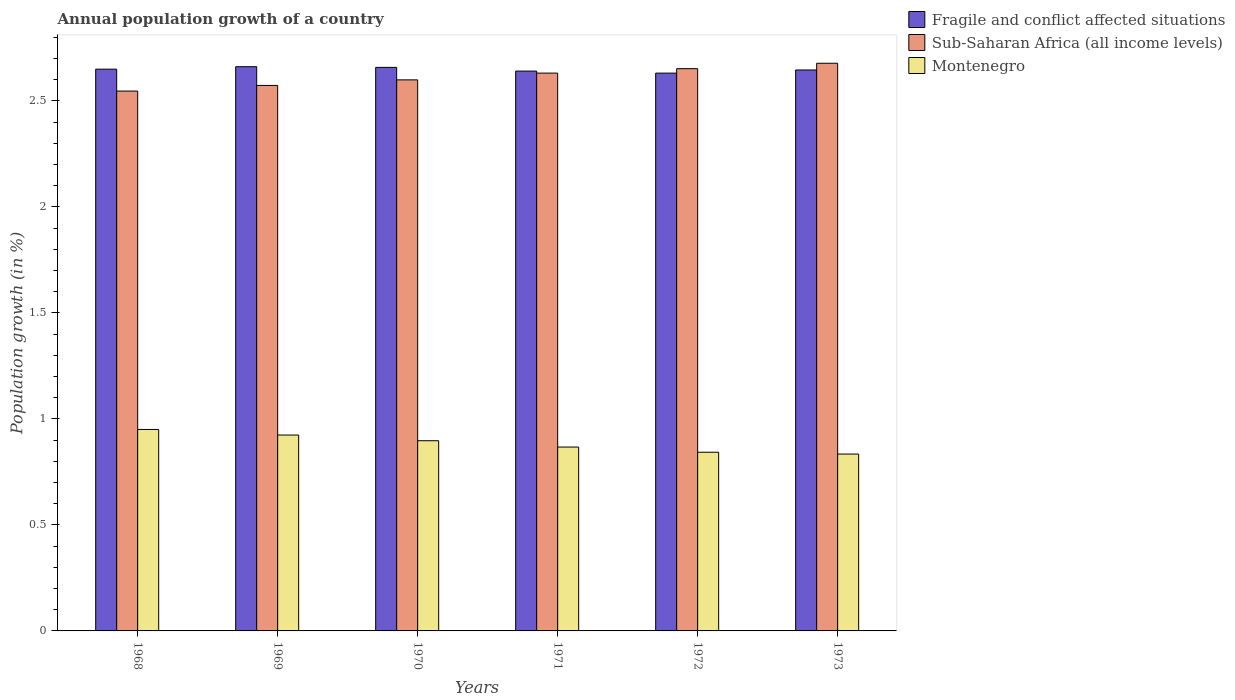How many different coloured bars are there?
Provide a succinct answer. 3. How many groups of bars are there?
Offer a very short reply. 6. Are the number of bars per tick equal to the number of legend labels?
Provide a short and direct response. Yes. How many bars are there on the 5th tick from the right?
Your response must be concise. 3. What is the annual population growth in Montenegro in 1968?
Make the answer very short. 0.95. Across all years, what is the maximum annual population growth in Sub-Saharan Africa (all income levels)?
Provide a succinct answer. 2.68. Across all years, what is the minimum annual population growth in Montenegro?
Give a very brief answer. 0.83. In which year was the annual population growth in Fragile and conflict affected situations maximum?
Offer a very short reply. 1969. In which year was the annual population growth in Sub-Saharan Africa (all income levels) minimum?
Provide a short and direct response. 1968. What is the total annual population growth in Fragile and conflict affected situations in the graph?
Offer a terse response. 15.89. What is the difference between the annual population growth in Fragile and conflict affected situations in 1970 and that in 1973?
Keep it short and to the point. 0.01. What is the difference between the annual population growth in Montenegro in 1969 and the annual population growth in Fragile and conflict affected situations in 1972?
Offer a very short reply. -1.71. What is the average annual population growth in Fragile and conflict affected situations per year?
Give a very brief answer. 2.65. In the year 1972, what is the difference between the annual population growth in Sub-Saharan Africa (all income levels) and annual population growth in Montenegro?
Offer a terse response. 1.81. What is the ratio of the annual population growth in Sub-Saharan Africa (all income levels) in 1970 to that in 1973?
Your answer should be very brief. 0.97. Is the difference between the annual population growth in Sub-Saharan Africa (all income levels) in 1971 and 1973 greater than the difference between the annual population growth in Montenegro in 1971 and 1973?
Provide a succinct answer. No. What is the difference between the highest and the second highest annual population growth in Montenegro?
Offer a very short reply. 0.03. What is the difference between the highest and the lowest annual population growth in Fragile and conflict affected situations?
Make the answer very short. 0.03. In how many years, is the annual population growth in Fragile and conflict affected situations greater than the average annual population growth in Fragile and conflict affected situations taken over all years?
Give a very brief answer. 3. What does the 3rd bar from the left in 1968 represents?
Provide a short and direct response. Montenegro. What does the 1st bar from the right in 1968 represents?
Offer a very short reply. Montenegro. Is it the case that in every year, the sum of the annual population growth in Montenegro and annual population growth in Sub-Saharan Africa (all income levels) is greater than the annual population growth in Fragile and conflict affected situations?
Provide a short and direct response. Yes. How many bars are there?
Provide a succinct answer. 18. What is the difference between two consecutive major ticks on the Y-axis?
Ensure brevity in your answer.  0.5. Are the values on the major ticks of Y-axis written in scientific E-notation?
Make the answer very short. No. Does the graph contain grids?
Make the answer very short. No. How are the legend labels stacked?
Keep it short and to the point. Vertical. What is the title of the graph?
Keep it short and to the point. Annual population growth of a country. What is the label or title of the X-axis?
Provide a succinct answer. Years. What is the label or title of the Y-axis?
Provide a succinct answer. Population growth (in %). What is the Population growth (in %) in Fragile and conflict affected situations in 1968?
Ensure brevity in your answer.  2.65. What is the Population growth (in %) of Sub-Saharan Africa (all income levels) in 1968?
Ensure brevity in your answer.  2.55. What is the Population growth (in %) in Montenegro in 1968?
Keep it short and to the point. 0.95. What is the Population growth (in %) in Fragile and conflict affected situations in 1969?
Your response must be concise. 2.66. What is the Population growth (in %) in Sub-Saharan Africa (all income levels) in 1969?
Keep it short and to the point. 2.57. What is the Population growth (in %) of Montenegro in 1969?
Provide a succinct answer. 0.92. What is the Population growth (in %) in Fragile and conflict affected situations in 1970?
Give a very brief answer. 2.66. What is the Population growth (in %) of Sub-Saharan Africa (all income levels) in 1970?
Provide a succinct answer. 2.6. What is the Population growth (in %) of Montenegro in 1970?
Provide a succinct answer. 0.9. What is the Population growth (in %) of Fragile and conflict affected situations in 1971?
Your answer should be compact. 2.64. What is the Population growth (in %) in Sub-Saharan Africa (all income levels) in 1971?
Ensure brevity in your answer.  2.63. What is the Population growth (in %) in Montenegro in 1971?
Ensure brevity in your answer.  0.87. What is the Population growth (in %) in Fragile and conflict affected situations in 1972?
Keep it short and to the point. 2.63. What is the Population growth (in %) in Sub-Saharan Africa (all income levels) in 1972?
Your answer should be very brief. 2.65. What is the Population growth (in %) of Montenegro in 1972?
Offer a very short reply. 0.84. What is the Population growth (in %) in Fragile and conflict affected situations in 1973?
Ensure brevity in your answer.  2.65. What is the Population growth (in %) of Sub-Saharan Africa (all income levels) in 1973?
Ensure brevity in your answer.  2.68. What is the Population growth (in %) in Montenegro in 1973?
Offer a terse response. 0.83. Across all years, what is the maximum Population growth (in %) of Fragile and conflict affected situations?
Your response must be concise. 2.66. Across all years, what is the maximum Population growth (in %) of Sub-Saharan Africa (all income levels)?
Offer a very short reply. 2.68. Across all years, what is the maximum Population growth (in %) in Montenegro?
Ensure brevity in your answer.  0.95. Across all years, what is the minimum Population growth (in %) in Fragile and conflict affected situations?
Ensure brevity in your answer.  2.63. Across all years, what is the minimum Population growth (in %) in Sub-Saharan Africa (all income levels)?
Give a very brief answer. 2.55. Across all years, what is the minimum Population growth (in %) of Montenegro?
Your response must be concise. 0.83. What is the total Population growth (in %) in Fragile and conflict affected situations in the graph?
Your response must be concise. 15.89. What is the total Population growth (in %) of Sub-Saharan Africa (all income levels) in the graph?
Offer a terse response. 15.68. What is the total Population growth (in %) in Montenegro in the graph?
Provide a short and direct response. 5.32. What is the difference between the Population growth (in %) of Fragile and conflict affected situations in 1968 and that in 1969?
Offer a terse response. -0.01. What is the difference between the Population growth (in %) of Sub-Saharan Africa (all income levels) in 1968 and that in 1969?
Your answer should be very brief. -0.03. What is the difference between the Population growth (in %) of Montenegro in 1968 and that in 1969?
Your answer should be very brief. 0.03. What is the difference between the Population growth (in %) in Fragile and conflict affected situations in 1968 and that in 1970?
Your answer should be very brief. -0.01. What is the difference between the Population growth (in %) in Sub-Saharan Africa (all income levels) in 1968 and that in 1970?
Provide a short and direct response. -0.05. What is the difference between the Population growth (in %) in Montenegro in 1968 and that in 1970?
Give a very brief answer. 0.05. What is the difference between the Population growth (in %) of Fragile and conflict affected situations in 1968 and that in 1971?
Your response must be concise. 0.01. What is the difference between the Population growth (in %) in Sub-Saharan Africa (all income levels) in 1968 and that in 1971?
Provide a succinct answer. -0.08. What is the difference between the Population growth (in %) of Montenegro in 1968 and that in 1971?
Ensure brevity in your answer.  0.08. What is the difference between the Population growth (in %) in Fragile and conflict affected situations in 1968 and that in 1972?
Give a very brief answer. 0.02. What is the difference between the Population growth (in %) of Sub-Saharan Africa (all income levels) in 1968 and that in 1972?
Ensure brevity in your answer.  -0.11. What is the difference between the Population growth (in %) of Montenegro in 1968 and that in 1972?
Ensure brevity in your answer.  0.11. What is the difference between the Population growth (in %) in Fragile and conflict affected situations in 1968 and that in 1973?
Offer a very short reply. 0. What is the difference between the Population growth (in %) in Sub-Saharan Africa (all income levels) in 1968 and that in 1973?
Your answer should be very brief. -0.13. What is the difference between the Population growth (in %) in Montenegro in 1968 and that in 1973?
Your answer should be very brief. 0.12. What is the difference between the Population growth (in %) of Fragile and conflict affected situations in 1969 and that in 1970?
Keep it short and to the point. 0. What is the difference between the Population growth (in %) of Sub-Saharan Africa (all income levels) in 1969 and that in 1970?
Offer a terse response. -0.03. What is the difference between the Population growth (in %) in Montenegro in 1969 and that in 1970?
Ensure brevity in your answer.  0.03. What is the difference between the Population growth (in %) in Fragile and conflict affected situations in 1969 and that in 1971?
Provide a succinct answer. 0.02. What is the difference between the Population growth (in %) of Sub-Saharan Africa (all income levels) in 1969 and that in 1971?
Offer a terse response. -0.06. What is the difference between the Population growth (in %) of Montenegro in 1969 and that in 1971?
Ensure brevity in your answer.  0.06. What is the difference between the Population growth (in %) of Fragile and conflict affected situations in 1969 and that in 1972?
Make the answer very short. 0.03. What is the difference between the Population growth (in %) in Sub-Saharan Africa (all income levels) in 1969 and that in 1972?
Offer a terse response. -0.08. What is the difference between the Population growth (in %) in Montenegro in 1969 and that in 1972?
Give a very brief answer. 0.08. What is the difference between the Population growth (in %) of Fragile and conflict affected situations in 1969 and that in 1973?
Your response must be concise. 0.02. What is the difference between the Population growth (in %) in Sub-Saharan Africa (all income levels) in 1969 and that in 1973?
Make the answer very short. -0.1. What is the difference between the Population growth (in %) of Montenegro in 1969 and that in 1973?
Keep it short and to the point. 0.09. What is the difference between the Population growth (in %) of Fragile and conflict affected situations in 1970 and that in 1971?
Your answer should be very brief. 0.02. What is the difference between the Population growth (in %) of Sub-Saharan Africa (all income levels) in 1970 and that in 1971?
Your answer should be very brief. -0.03. What is the difference between the Population growth (in %) of Montenegro in 1970 and that in 1971?
Ensure brevity in your answer.  0.03. What is the difference between the Population growth (in %) of Fragile and conflict affected situations in 1970 and that in 1972?
Provide a short and direct response. 0.03. What is the difference between the Population growth (in %) in Sub-Saharan Africa (all income levels) in 1970 and that in 1972?
Give a very brief answer. -0.05. What is the difference between the Population growth (in %) of Montenegro in 1970 and that in 1972?
Your response must be concise. 0.05. What is the difference between the Population growth (in %) in Fragile and conflict affected situations in 1970 and that in 1973?
Make the answer very short. 0.01. What is the difference between the Population growth (in %) of Sub-Saharan Africa (all income levels) in 1970 and that in 1973?
Offer a very short reply. -0.08. What is the difference between the Population growth (in %) in Montenegro in 1970 and that in 1973?
Keep it short and to the point. 0.06. What is the difference between the Population growth (in %) in Fragile and conflict affected situations in 1971 and that in 1972?
Provide a short and direct response. 0.01. What is the difference between the Population growth (in %) in Sub-Saharan Africa (all income levels) in 1971 and that in 1972?
Offer a terse response. -0.02. What is the difference between the Population growth (in %) in Montenegro in 1971 and that in 1972?
Your answer should be very brief. 0.02. What is the difference between the Population growth (in %) of Fragile and conflict affected situations in 1971 and that in 1973?
Provide a succinct answer. -0.01. What is the difference between the Population growth (in %) of Sub-Saharan Africa (all income levels) in 1971 and that in 1973?
Provide a succinct answer. -0.05. What is the difference between the Population growth (in %) of Montenegro in 1971 and that in 1973?
Give a very brief answer. 0.03. What is the difference between the Population growth (in %) of Fragile and conflict affected situations in 1972 and that in 1973?
Provide a succinct answer. -0.01. What is the difference between the Population growth (in %) in Sub-Saharan Africa (all income levels) in 1972 and that in 1973?
Keep it short and to the point. -0.03. What is the difference between the Population growth (in %) in Montenegro in 1972 and that in 1973?
Your response must be concise. 0.01. What is the difference between the Population growth (in %) of Fragile and conflict affected situations in 1968 and the Population growth (in %) of Sub-Saharan Africa (all income levels) in 1969?
Offer a very short reply. 0.08. What is the difference between the Population growth (in %) in Fragile and conflict affected situations in 1968 and the Population growth (in %) in Montenegro in 1969?
Your answer should be compact. 1.73. What is the difference between the Population growth (in %) in Sub-Saharan Africa (all income levels) in 1968 and the Population growth (in %) in Montenegro in 1969?
Your response must be concise. 1.62. What is the difference between the Population growth (in %) of Fragile and conflict affected situations in 1968 and the Population growth (in %) of Sub-Saharan Africa (all income levels) in 1970?
Make the answer very short. 0.05. What is the difference between the Population growth (in %) in Fragile and conflict affected situations in 1968 and the Population growth (in %) in Montenegro in 1970?
Provide a succinct answer. 1.75. What is the difference between the Population growth (in %) of Sub-Saharan Africa (all income levels) in 1968 and the Population growth (in %) of Montenegro in 1970?
Make the answer very short. 1.65. What is the difference between the Population growth (in %) in Fragile and conflict affected situations in 1968 and the Population growth (in %) in Sub-Saharan Africa (all income levels) in 1971?
Offer a terse response. 0.02. What is the difference between the Population growth (in %) in Fragile and conflict affected situations in 1968 and the Population growth (in %) in Montenegro in 1971?
Offer a very short reply. 1.78. What is the difference between the Population growth (in %) of Sub-Saharan Africa (all income levels) in 1968 and the Population growth (in %) of Montenegro in 1971?
Offer a very short reply. 1.68. What is the difference between the Population growth (in %) of Fragile and conflict affected situations in 1968 and the Population growth (in %) of Sub-Saharan Africa (all income levels) in 1972?
Your answer should be compact. -0. What is the difference between the Population growth (in %) in Fragile and conflict affected situations in 1968 and the Population growth (in %) in Montenegro in 1972?
Offer a terse response. 1.81. What is the difference between the Population growth (in %) of Sub-Saharan Africa (all income levels) in 1968 and the Population growth (in %) of Montenegro in 1972?
Make the answer very short. 1.7. What is the difference between the Population growth (in %) in Fragile and conflict affected situations in 1968 and the Population growth (in %) in Sub-Saharan Africa (all income levels) in 1973?
Make the answer very short. -0.03. What is the difference between the Population growth (in %) of Fragile and conflict affected situations in 1968 and the Population growth (in %) of Montenegro in 1973?
Offer a very short reply. 1.82. What is the difference between the Population growth (in %) of Sub-Saharan Africa (all income levels) in 1968 and the Population growth (in %) of Montenegro in 1973?
Offer a very short reply. 1.71. What is the difference between the Population growth (in %) of Fragile and conflict affected situations in 1969 and the Population growth (in %) of Sub-Saharan Africa (all income levels) in 1970?
Provide a succinct answer. 0.06. What is the difference between the Population growth (in %) of Fragile and conflict affected situations in 1969 and the Population growth (in %) of Montenegro in 1970?
Your answer should be compact. 1.76. What is the difference between the Population growth (in %) of Sub-Saharan Africa (all income levels) in 1969 and the Population growth (in %) of Montenegro in 1970?
Your answer should be very brief. 1.68. What is the difference between the Population growth (in %) of Fragile and conflict affected situations in 1969 and the Population growth (in %) of Sub-Saharan Africa (all income levels) in 1971?
Provide a succinct answer. 0.03. What is the difference between the Population growth (in %) in Fragile and conflict affected situations in 1969 and the Population growth (in %) in Montenegro in 1971?
Provide a short and direct response. 1.79. What is the difference between the Population growth (in %) in Sub-Saharan Africa (all income levels) in 1969 and the Population growth (in %) in Montenegro in 1971?
Your answer should be very brief. 1.71. What is the difference between the Population growth (in %) of Fragile and conflict affected situations in 1969 and the Population growth (in %) of Sub-Saharan Africa (all income levels) in 1972?
Your answer should be very brief. 0.01. What is the difference between the Population growth (in %) in Fragile and conflict affected situations in 1969 and the Population growth (in %) in Montenegro in 1972?
Offer a terse response. 1.82. What is the difference between the Population growth (in %) of Sub-Saharan Africa (all income levels) in 1969 and the Population growth (in %) of Montenegro in 1972?
Ensure brevity in your answer.  1.73. What is the difference between the Population growth (in %) in Fragile and conflict affected situations in 1969 and the Population growth (in %) in Sub-Saharan Africa (all income levels) in 1973?
Your answer should be compact. -0.02. What is the difference between the Population growth (in %) of Fragile and conflict affected situations in 1969 and the Population growth (in %) of Montenegro in 1973?
Offer a terse response. 1.83. What is the difference between the Population growth (in %) of Sub-Saharan Africa (all income levels) in 1969 and the Population growth (in %) of Montenegro in 1973?
Make the answer very short. 1.74. What is the difference between the Population growth (in %) of Fragile and conflict affected situations in 1970 and the Population growth (in %) of Sub-Saharan Africa (all income levels) in 1971?
Ensure brevity in your answer.  0.03. What is the difference between the Population growth (in %) of Fragile and conflict affected situations in 1970 and the Population growth (in %) of Montenegro in 1971?
Offer a terse response. 1.79. What is the difference between the Population growth (in %) in Sub-Saharan Africa (all income levels) in 1970 and the Population growth (in %) in Montenegro in 1971?
Your answer should be compact. 1.73. What is the difference between the Population growth (in %) of Fragile and conflict affected situations in 1970 and the Population growth (in %) of Sub-Saharan Africa (all income levels) in 1972?
Keep it short and to the point. 0.01. What is the difference between the Population growth (in %) of Fragile and conflict affected situations in 1970 and the Population growth (in %) of Montenegro in 1972?
Offer a very short reply. 1.82. What is the difference between the Population growth (in %) in Sub-Saharan Africa (all income levels) in 1970 and the Population growth (in %) in Montenegro in 1972?
Your answer should be compact. 1.76. What is the difference between the Population growth (in %) in Fragile and conflict affected situations in 1970 and the Population growth (in %) in Sub-Saharan Africa (all income levels) in 1973?
Offer a very short reply. -0.02. What is the difference between the Population growth (in %) in Fragile and conflict affected situations in 1970 and the Population growth (in %) in Montenegro in 1973?
Your answer should be compact. 1.82. What is the difference between the Population growth (in %) in Sub-Saharan Africa (all income levels) in 1970 and the Population growth (in %) in Montenegro in 1973?
Provide a succinct answer. 1.77. What is the difference between the Population growth (in %) in Fragile and conflict affected situations in 1971 and the Population growth (in %) in Sub-Saharan Africa (all income levels) in 1972?
Keep it short and to the point. -0.01. What is the difference between the Population growth (in %) of Fragile and conflict affected situations in 1971 and the Population growth (in %) of Montenegro in 1972?
Your answer should be very brief. 1.8. What is the difference between the Population growth (in %) in Sub-Saharan Africa (all income levels) in 1971 and the Population growth (in %) in Montenegro in 1972?
Ensure brevity in your answer.  1.79. What is the difference between the Population growth (in %) of Fragile and conflict affected situations in 1971 and the Population growth (in %) of Sub-Saharan Africa (all income levels) in 1973?
Provide a succinct answer. -0.04. What is the difference between the Population growth (in %) in Fragile and conflict affected situations in 1971 and the Population growth (in %) in Montenegro in 1973?
Give a very brief answer. 1.81. What is the difference between the Population growth (in %) of Sub-Saharan Africa (all income levels) in 1971 and the Population growth (in %) of Montenegro in 1973?
Your response must be concise. 1.8. What is the difference between the Population growth (in %) in Fragile and conflict affected situations in 1972 and the Population growth (in %) in Sub-Saharan Africa (all income levels) in 1973?
Your response must be concise. -0.05. What is the difference between the Population growth (in %) in Fragile and conflict affected situations in 1972 and the Population growth (in %) in Montenegro in 1973?
Provide a succinct answer. 1.8. What is the difference between the Population growth (in %) of Sub-Saharan Africa (all income levels) in 1972 and the Population growth (in %) of Montenegro in 1973?
Provide a short and direct response. 1.82. What is the average Population growth (in %) in Fragile and conflict affected situations per year?
Keep it short and to the point. 2.65. What is the average Population growth (in %) of Sub-Saharan Africa (all income levels) per year?
Give a very brief answer. 2.61. What is the average Population growth (in %) of Montenegro per year?
Keep it short and to the point. 0.89. In the year 1968, what is the difference between the Population growth (in %) of Fragile and conflict affected situations and Population growth (in %) of Sub-Saharan Africa (all income levels)?
Your answer should be compact. 0.1. In the year 1968, what is the difference between the Population growth (in %) in Fragile and conflict affected situations and Population growth (in %) in Montenegro?
Your answer should be compact. 1.7. In the year 1968, what is the difference between the Population growth (in %) in Sub-Saharan Africa (all income levels) and Population growth (in %) in Montenegro?
Offer a terse response. 1.6. In the year 1969, what is the difference between the Population growth (in %) in Fragile and conflict affected situations and Population growth (in %) in Sub-Saharan Africa (all income levels)?
Offer a very short reply. 0.09. In the year 1969, what is the difference between the Population growth (in %) of Fragile and conflict affected situations and Population growth (in %) of Montenegro?
Your response must be concise. 1.74. In the year 1969, what is the difference between the Population growth (in %) in Sub-Saharan Africa (all income levels) and Population growth (in %) in Montenegro?
Keep it short and to the point. 1.65. In the year 1970, what is the difference between the Population growth (in %) of Fragile and conflict affected situations and Population growth (in %) of Sub-Saharan Africa (all income levels)?
Provide a short and direct response. 0.06. In the year 1970, what is the difference between the Population growth (in %) in Fragile and conflict affected situations and Population growth (in %) in Montenegro?
Give a very brief answer. 1.76. In the year 1970, what is the difference between the Population growth (in %) of Sub-Saharan Africa (all income levels) and Population growth (in %) of Montenegro?
Keep it short and to the point. 1.7. In the year 1971, what is the difference between the Population growth (in %) of Fragile and conflict affected situations and Population growth (in %) of Sub-Saharan Africa (all income levels)?
Make the answer very short. 0.01. In the year 1971, what is the difference between the Population growth (in %) of Fragile and conflict affected situations and Population growth (in %) of Montenegro?
Provide a short and direct response. 1.77. In the year 1971, what is the difference between the Population growth (in %) in Sub-Saharan Africa (all income levels) and Population growth (in %) in Montenegro?
Make the answer very short. 1.76. In the year 1972, what is the difference between the Population growth (in %) of Fragile and conflict affected situations and Population growth (in %) of Sub-Saharan Africa (all income levels)?
Your answer should be compact. -0.02. In the year 1972, what is the difference between the Population growth (in %) in Fragile and conflict affected situations and Population growth (in %) in Montenegro?
Keep it short and to the point. 1.79. In the year 1972, what is the difference between the Population growth (in %) of Sub-Saharan Africa (all income levels) and Population growth (in %) of Montenegro?
Keep it short and to the point. 1.81. In the year 1973, what is the difference between the Population growth (in %) of Fragile and conflict affected situations and Population growth (in %) of Sub-Saharan Africa (all income levels)?
Offer a terse response. -0.03. In the year 1973, what is the difference between the Population growth (in %) in Fragile and conflict affected situations and Population growth (in %) in Montenegro?
Ensure brevity in your answer.  1.81. In the year 1973, what is the difference between the Population growth (in %) in Sub-Saharan Africa (all income levels) and Population growth (in %) in Montenegro?
Offer a terse response. 1.84. What is the ratio of the Population growth (in %) in Montenegro in 1968 to that in 1969?
Provide a succinct answer. 1.03. What is the ratio of the Population growth (in %) of Sub-Saharan Africa (all income levels) in 1968 to that in 1970?
Your answer should be compact. 0.98. What is the ratio of the Population growth (in %) of Montenegro in 1968 to that in 1970?
Provide a short and direct response. 1.06. What is the ratio of the Population growth (in %) of Sub-Saharan Africa (all income levels) in 1968 to that in 1971?
Your answer should be compact. 0.97. What is the ratio of the Population growth (in %) of Montenegro in 1968 to that in 1971?
Keep it short and to the point. 1.1. What is the ratio of the Population growth (in %) in Fragile and conflict affected situations in 1968 to that in 1972?
Give a very brief answer. 1.01. What is the ratio of the Population growth (in %) of Sub-Saharan Africa (all income levels) in 1968 to that in 1972?
Provide a short and direct response. 0.96. What is the ratio of the Population growth (in %) of Montenegro in 1968 to that in 1972?
Your answer should be very brief. 1.13. What is the ratio of the Population growth (in %) in Fragile and conflict affected situations in 1968 to that in 1973?
Make the answer very short. 1. What is the ratio of the Population growth (in %) of Sub-Saharan Africa (all income levels) in 1968 to that in 1973?
Keep it short and to the point. 0.95. What is the ratio of the Population growth (in %) in Montenegro in 1968 to that in 1973?
Your answer should be compact. 1.14. What is the ratio of the Population growth (in %) of Sub-Saharan Africa (all income levels) in 1969 to that in 1971?
Offer a very short reply. 0.98. What is the ratio of the Population growth (in %) in Montenegro in 1969 to that in 1971?
Your response must be concise. 1.07. What is the ratio of the Population growth (in %) in Fragile and conflict affected situations in 1969 to that in 1972?
Make the answer very short. 1.01. What is the ratio of the Population growth (in %) of Sub-Saharan Africa (all income levels) in 1969 to that in 1972?
Offer a very short reply. 0.97. What is the ratio of the Population growth (in %) in Montenegro in 1969 to that in 1972?
Your answer should be compact. 1.1. What is the ratio of the Population growth (in %) of Fragile and conflict affected situations in 1969 to that in 1973?
Provide a succinct answer. 1.01. What is the ratio of the Population growth (in %) in Sub-Saharan Africa (all income levels) in 1969 to that in 1973?
Offer a terse response. 0.96. What is the ratio of the Population growth (in %) of Montenegro in 1969 to that in 1973?
Your response must be concise. 1.11. What is the ratio of the Population growth (in %) in Fragile and conflict affected situations in 1970 to that in 1971?
Your answer should be compact. 1.01. What is the ratio of the Population growth (in %) in Sub-Saharan Africa (all income levels) in 1970 to that in 1971?
Keep it short and to the point. 0.99. What is the ratio of the Population growth (in %) of Montenegro in 1970 to that in 1971?
Your answer should be compact. 1.03. What is the ratio of the Population growth (in %) of Fragile and conflict affected situations in 1970 to that in 1972?
Your response must be concise. 1.01. What is the ratio of the Population growth (in %) in Sub-Saharan Africa (all income levels) in 1970 to that in 1972?
Ensure brevity in your answer.  0.98. What is the ratio of the Population growth (in %) of Montenegro in 1970 to that in 1972?
Your answer should be compact. 1.06. What is the ratio of the Population growth (in %) of Sub-Saharan Africa (all income levels) in 1970 to that in 1973?
Give a very brief answer. 0.97. What is the ratio of the Population growth (in %) of Montenegro in 1970 to that in 1973?
Offer a terse response. 1.08. What is the ratio of the Population growth (in %) in Fragile and conflict affected situations in 1971 to that in 1972?
Provide a short and direct response. 1. What is the ratio of the Population growth (in %) of Sub-Saharan Africa (all income levels) in 1971 to that in 1972?
Provide a succinct answer. 0.99. What is the ratio of the Population growth (in %) of Montenegro in 1971 to that in 1972?
Keep it short and to the point. 1.03. What is the ratio of the Population growth (in %) in Sub-Saharan Africa (all income levels) in 1971 to that in 1973?
Your answer should be compact. 0.98. What is the ratio of the Population growth (in %) in Montenegro in 1971 to that in 1973?
Make the answer very short. 1.04. What is the ratio of the Population growth (in %) of Sub-Saharan Africa (all income levels) in 1972 to that in 1973?
Offer a very short reply. 0.99. What is the ratio of the Population growth (in %) in Montenegro in 1972 to that in 1973?
Provide a short and direct response. 1.01. What is the difference between the highest and the second highest Population growth (in %) in Fragile and conflict affected situations?
Offer a very short reply. 0. What is the difference between the highest and the second highest Population growth (in %) in Sub-Saharan Africa (all income levels)?
Offer a very short reply. 0.03. What is the difference between the highest and the second highest Population growth (in %) of Montenegro?
Make the answer very short. 0.03. What is the difference between the highest and the lowest Population growth (in %) of Fragile and conflict affected situations?
Provide a short and direct response. 0.03. What is the difference between the highest and the lowest Population growth (in %) of Sub-Saharan Africa (all income levels)?
Keep it short and to the point. 0.13. What is the difference between the highest and the lowest Population growth (in %) of Montenegro?
Give a very brief answer. 0.12. 